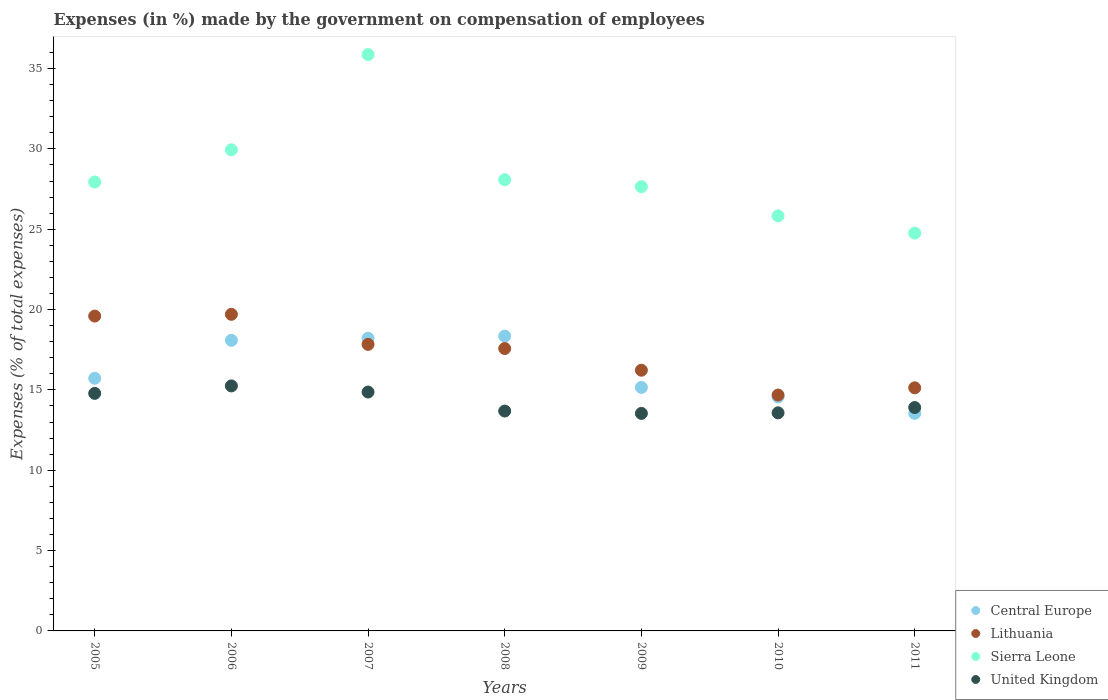How many different coloured dotlines are there?
Your answer should be compact. 4. Is the number of dotlines equal to the number of legend labels?
Offer a very short reply. Yes. What is the percentage of expenses made by the government on compensation of employees in Sierra Leone in 2005?
Keep it short and to the point. 27.94. Across all years, what is the maximum percentage of expenses made by the government on compensation of employees in United Kingdom?
Your answer should be compact. 15.25. Across all years, what is the minimum percentage of expenses made by the government on compensation of employees in Sierra Leone?
Your answer should be compact. 24.76. In which year was the percentage of expenses made by the government on compensation of employees in Sierra Leone minimum?
Keep it short and to the point. 2011. What is the total percentage of expenses made by the government on compensation of employees in Central Europe in the graph?
Offer a very short reply. 113.63. What is the difference between the percentage of expenses made by the government on compensation of employees in United Kingdom in 2006 and that in 2008?
Your answer should be very brief. 1.56. What is the difference between the percentage of expenses made by the government on compensation of employees in Central Europe in 2011 and the percentage of expenses made by the government on compensation of employees in Lithuania in 2007?
Your answer should be compact. -4.3. What is the average percentage of expenses made by the government on compensation of employees in Lithuania per year?
Offer a terse response. 17.25. In the year 2007, what is the difference between the percentage of expenses made by the government on compensation of employees in Central Europe and percentage of expenses made by the government on compensation of employees in United Kingdom?
Provide a short and direct response. 3.35. In how many years, is the percentage of expenses made by the government on compensation of employees in Central Europe greater than 27 %?
Offer a terse response. 0. What is the ratio of the percentage of expenses made by the government on compensation of employees in Central Europe in 2007 to that in 2011?
Keep it short and to the point. 1.35. Is the difference between the percentage of expenses made by the government on compensation of employees in Central Europe in 2005 and 2011 greater than the difference between the percentage of expenses made by the government on compensation of employees in United Kingdom in 2005 and 2011?
Ensure brevity in your answer.  Yes. What is the difference between the highest and the second highest percentage of expenses made by the government on compensation of employees in Lithuania?
Your answer should be very brief. 0.11. What is the difference between the highest and the lowest percentage of expenses made by the government on compensation of employees in Sierra Leone?
Provide a short and direct response. 11.11. Is it the case that in every year, the sum of the percentage of expenses made by the government on compensation of employees in Lithuania and percentage of expenses made by the government on compensation of employees in United Kingdom  is greater than the sum of percentage of expenses made by the government on compensation of employees in Central Europe and percentage of expenses made by the government on compensation of employees in Sierra Leone?
Make the answer very short. No. Is it the case that in every year, the sum of the percentage of expenses made by the government on compensation of employees in Lithuania and percentage of expenses made by the government on compensation of employees in Central Europe  is greater than the percentage of expenses made by the government on compensation of employees in United Kingdom?
Give a very brief answer. Yes. Does the percentage of expenses made by the government on compensation of employees in Sierra Leone monotonically increase over the years?
Your answer should be very brief. No. Is the percentage of expenses made by the government on compensation of employees in United Kingdom strictly less than the percentage of expenses made by the government on compensation of employees in Lithuania over the years?
Provide a short and direct response. Yes. How many years are there in the graph?
Provide a short and direct response. 7. Are the values on the major ticks of Y-axis written in scientific E-notation?
Offer a very short reply. No. Does the graph contain any zero values?
Offer a very short reply. No. Does the graph contain grids?
Your response must be concise. No. Where does the legend appear in the graph?
Keep it short and to the point. Bottom right. How many legend labels are there?
Offer a very short reply. 4. How are the legend labels stacked?
Keep it short and to the point. Vertical. What is the title of the graph?
Your answer should be compact. Expenses (in %) made by the government on compensation of employees. What is the label or title of the X-axis?
Your response must be concise. Years. What is the label or title of the Y-axis?
Your response must be concise. Expenses (% of total expenses). What is the Expenses (% of total expenses) in Central Europe in 2005?
Your answer should be compact. 15.72. What is the Expenses (% of total expenses) in Lithuania in 2005?
Provide a short and direct response. 19.59. What is the Expenses (% of total expenses) of Sierra Leone in 2005?
Your answer should be very brief. 27.94. What is the Expenses (% of total expenses) of United Kingdom in 2005?
Keep it short and to the point. 14.78. What is the Expenses (% of total expenses) of Central Europe in 2006?
Ensure brevity in your answer.  18.09. What is the Expenses (% of total expenses) in Lithuania in 2006?
Keep it short and to the point. 19.7. What is the Expenses (% of total expenses) in Sierra Leone in 2006?
Your answer should be compact. 29.94. What is the Expenses (% of total expenses) of United Kingdom in 2006?
Ensure brevity in your answer.  15.25. What is the Expenses (% of total expenses) in Central Europe in 2007?
Provide a succinct answer. 18.22. What is the Expenses (% of total expenses) in Lithuania in 2007?
Your response must be concise. 17.83. What is the Expenses (% of total expenses) of Sierra Leone in 2007?
Provide a succinct answer. 35.87. What is the Expenses (% of total expenses) of United Kingdom in 2007?
Ensure brevity in your answer.  14.87. What is the Expenses (% of total expenses) of Central Europe in 2008?
Keep it short and to the point. 18.35. What is the Expenses (% of total expenses) of Lithuania in 2008?
Offer a very short reply. 17.57. What is the Expenses (% of total expenses) of Sierra Leone in 2008?
Make the answer very short. 28.08. What is the Expenses (% of total expenses) of United Kingdom in 2008?
Your answer should be very brief. 13.68. What is the Expenses (% of total expenses) of Central Europe in 2009?
Provide a succinct answer. 15.16. What is the Expenses (% of total expenses) in Lithuania in 2009?
Your answer should be very brief. 16.23. What is the Expenses (% of total expenses) of Sierra Leone in 2009?
Offer a very short reply. 27.65. What is the Expenses (% of total expenses) of United Kingdom in 2009?
Ensure brevity in your answer.  13.54. What is the Expenses (% of total expenses) in Central Europe in 2010?
Give a very brief answer. 14.56. What is the Expenses (% of total expenses) of Lithuania in 2010?
Provide a short and direct response. 14.68. What is the Expenses (% of total expenses) in Sierra Leone in 2010?
Your answer should be very brief. 25.83. What is the Expenses (% of total expenses) in United Kingdom in 2010?
Provide a succinct answer. 13.57. What is the Expenses (% of total expenses) of Central Europe in 2011?
Your answer should be very brief. 13.54. What is the Expenses (% of total expenses) of Lithuania in 2011?
Provide a succinct answer. 15.13. What is the Expenses (% of total expenses) in Sierra Leone in 2011?
Your response must be concise. 24.76. What is the Expenses (% of total expenses) in United Kingdom in 2011?
Your response must be concise. 13.9. Across all years, what is the maximum Expenses (% of total expenses) of Central Europe?
Provide a succinct answer. 18.35. Across all years, what is the maximum Expenses (% of total expenses) of Lithuania?
Your answer should be compact. 19.7. Across all years, what is the maximum Expenses (% of total expenses) in Sierra Leone?
Provide a short and direct response. 35.87. Across all years, what is the maximum Expenses (% of total expenses) in United Kingdom?
Offer a very short reply. 15.25. Across all years, what is the minimum Expenses (% of total expenses) in Central Europe?
Provide a short and direct response. 13.54. Across all years, what is the minimum Expenses (% of total expenses) in Lithuania?
Give a very brief answer. 14.68. Across all years, what is the minimum Expenses (% of total expenses) in Sierra Leone?
Make the answer very short. 24.76. Across all years, what is the minimum Expenses (% of total expenses) of United Kingdom?
Your response must be concise. 13.54. What is the total Expenses (% of total expenses) in Central Europe in the graph?
Make the answer very short. 113.63. What is the total Expenses (% of total expenses) in Lithuania in the graph?
Your response must be concise. 120.74. What is the total Expenses (% of total expenses) in Sierra Leone in the graph?
Provide a short and direct response. 200.08. What is the total Expenses (% of total expenses) in United Kingdom in the graph?
Your answer should be very brief. 99.6. What is the difference between the Expenses (% of total expenses) of Central Europe in 2005 and that in 2006?
Offer a very short reply. -2.36. What is the difference between the Expenses (% of total expenses) of Lithuania in 2005 and that in 2006?
Keep it short and to the point. -0.11. What is the difference between the Expenses (% of total expenses) of Sierra Leone in 2005 and that in 2006?
Your answer should be compact. -2. What is the difference between the Expenses (% of total expenses) of United Kingdom in 2005 and that in 2006?
Keep it short and to the point. -0.47. What is the difference between the Expenses (% of total expenses) in Central Europe in 2005 and that in 2007?
Make the answer very short. -2.49. What is the difference between the Expenses (% of total expenses) in Lithuania in 2005 and that in 2007?
Offer a very short reply. 1.76. What is the difference between the Expenses (% of total expenses) in Sierra Leone in 2005 and that in 2007?
Provide a short and direct response. -7.93. What is the difference between the Expenses (% of total expenses) in United Kingdom in 2005 and that in 2007?
Your answer should be very brief. -0.08. What is the difference between the Expenses (% of total expenses) of Central Europe in 2005 and that in 2008?
Ensure brevity in your answer.  -2.63. What is the difference between the Expenses (% of total expenses) of Lithuania in 2005 and that in 2008?
Make the answer very short. 2.02. What is the difference between the Expenses (% of total expenses) in Sierra Leone in 2005 and that in 2008?
Make the answer very short. -0.14. What is the difference between the Expenses (% of total expenses) of United Kingdom in 2005 and that in 2008?
Make the answer very short. 1.1. What is the difference between the Expenses (% of total expenses) in Central Europe in 2005 and that in 2009?
Your answer should be compact. 0.57. What is the difference between the Expenses (% of total expenses) in Lithuania in 2005 and that in 2009?
Your answer should be compact. 3.37. What is the difference between the Expenses (% of total expenses) of Sierra Leone in 2005 and that in 2009?
Your answer should be compact. 0.29. What is the difference between the Expenses (% of total expenses) of United Kingdom in 2005 and that in 2009?
Provide a succinct answer. 1.25. What is the difference between the Expenses (% of total expenses) of Central Europe in 2005 and that in 2010?
Offer a terse response. 1.16. What is the difference between the Expenses (% of total expenses) of Lithuania in 2005 and that in 2010?
Your response must be concise. 4.91. What is the difference between the Expenses (% of total expenses) in Sierra Leone in 2005 and that in 2010?
Provide a succinct answer. 2.11. What is the difference between the Expenses (% of total expenses) of United Kingdom in 2005 and that in 2010?
Give a very brief answer. 1.21. What is the difference between the Expenses (% of total expenses) in Central Europe in 2005 and that in 2011?
Your answer should be very brief. 2.18. What is the difference between the Expenses (% of total expenses) in Lithuania in 2005 and that in 2011?
Your answer should be very brief. 4.46. What is the difference between the Expenses (% of total expenses) in Sierra Leone in 2005 and that in 2011?
Provide a short and direct response. 3.18. What is the difference between the Expenses (% of total expenses) of United Kingdom in 2005 and that in 2011?
Keep it short and to the point. 0.88. What is the difference between the Expenses (% of total expenses) in Central Europe in 2006 and that in 2007?
Make the answer very short. -0.13. What is the difference between the Expenses (% of total expenses) of Lithuania in 2006 and that in 2007?
Your answer should be very brief. 1.87. What is the difference between the Expenses (% of total expenses) in Sierra Leone in 2006 and that in 2007?
Offer a terse response. -5.93. What is the difference between the Expenses (% of total expenses) of United Kingdom in 2006 and that in 2007?
Your response must be concise. 0.38. What is the difference between the Expenses (% of total expenses) of Central Europe in 2006 and that in 2008?
Offer a terse response. -0.26. What is the difference between the Expenses (% of total expenses) of Lithuania in 2006 and that in 2008?
Ensure brevity in your answer.  2.13. What is the difference between the Expenses (% of total expenses) of Sierra Leone in 2006 and that in 2008?
Offer a terse response. 1.86. What is the difference between the Expenses (% of total expenses) in United Kingdom in 2006 and that in 2008?
Give a very brief answer. 1.56. What is the difference between the Expenses (% of total expenses) in Central Europe in 2006 and that in 2009?
Give a very brief answer. 2.93. What is the difference between the Expenses (% of total expenses) in Lithuania in 2006 and that in 2009?
Give a very brief answer. 3.48. What is the difference between the Expenses (% of total expenses) in Sierra Leone in 2006 and that in 2009?
Your response must be concise. 2.29. What is the difference between the Expenses (% of total expenses) of United Kingdom in 2006 and that in 2009?
Ensure brevity in your answer.  1.71. What is the difference between the Expenses (% of total expenses) of Central Europe in 2006 and that in 2010?
Ensure brevity in your answer.  3.53. What is the difference between the Expenses (% of total expenses) of Lithuania in 2006 and that in 2010?
Ensure brevity in your answer.  5.02. What is the difference between the Expenses (% of total expenses) of Sierra Leone in 2006 and that in 2010?
Your answer should be very brief. 4.11. What is the difference between the Expenses (% of total expenses) of United Kingdom in 2006 and that in 2010?
Make the answer very short. 1.67. What is the difference between the Expenses (% of total expenses) in Central Europe in 2006 and that in 2011?
Provide a short and direct response. 4.55. What is the difference between the Expenses (% of total expenses) in Lithuania in 2006 and that in 2011?
Keep it short and to the point. 4.57. What is the difference between the Expenses (% of total expenses) of Sierra Leone in 2006 and that in 2011?
Ensure brevity in your answer.  5.18. What is the difference between the Expenses (% of total expenses) of United Kingdom in 2006 and that in 2011?
Your answer should be very brief. 1.35. What is the difference between the Expenses (% of total expenses) of Central Europe in 2007 and that in 2008?
Ensure brevity in your answer.  -0.13. What is the difference between the Expenses (% of total expenses) in Lithuania in 2007 and that in 2008?
Your response must be concise. 0.26. What is the difference between the Expenses (% of total expenses) of Sierra Leone in 2007 and that in 2008?
Give a very brief answer. 7.79. What is the difference between the Expenses (% of total expenses) in United Kingdom in 2007 and that in 2008?
Offer a very short reply. 1.18. What is the difference between the Expenses (% of total expenses) in Central Europe in 2007 and that in 2009?
Your answer should be compact. 3.06. What is the difference between the Expenses (% of total expenses) of Lithuania in 2007 and that in 2009?
Offer a terse response. 1.61. What is the difference between the Expenses (% of total expenses) in Sierra Leone in 2007 and that in 2009?
Give a very brief answer. 8.22. What is the difference between the Expenses (% of total expenses) of United Kingdom in 2007 and that in 2009?
Offer a very short reply. 1.33. What is the difference between the Expenses (% of total expenses) in Central Europe in 2007 and that in 2010?
Offer a very short reply. 3.65. What is the difference between the Expenses (% of total expenses) of Lithuania in 2007 and that in 2010?
Keep it short and to the point. 3.15. What is the difference between the Expenses (% of total expenses) of Sierra Leone in 2007 and that in 2010?
Provide a short and direct response. 10.04. What is the difference between the Expenses (% of total expenses) in United Kingdom in 2007 and that in 2010?
Your answer should be compact. 1.29. What is the difference between the Expenses (% of total expenses) of Central Europe in 2007 and that in 2011?
Provide a succinct answer. 4.68. What is the difference between the Expenses (% of total expenses) in Lithuania in 2007 and that in 2011?
Make the answer very short. 2.7. What is the difference between the Expenses (% of total expenses) of Sierra Leone in 2007 and that in 2011?
Provide a short and direct response. 11.11. What is the difference between the Expenses (% of total expenses) in United Kingdom in 2007 and that in 2011?
Your response must be concise. 0.97. What is the difference between the Expenses (% of total expenses) in Central Europe in 2008 and that in 2009?
Your response must be concise. 3.19. What is the difference between the Expenses (% of total expenses) of Lithuania in 2008 and that in 2009?
Give a very brief answer. 1.35. What is the difference between the Expenses (% of total expenses) in Sierra Leone in 2008 and that in 2009?
Provide a short and direct response. 0.43. What is the difference between the Expenses (% of total expenses) of United Kingdom in 2008 and that in 2009?
Offer a very short reply. 0.15. What is the difference between the Expenses (% of total expenses) in Central Europe in 2008 and that in 2010?
Your answer should be very brief. 3.79. What is the difference between the Expenses (% of total expenses) of Lithuania in 2008 and that in 2010?
Make the answer very short. 2.89. What is the difference between the Expenses (% of total expenses) in Sierra Leone in 2008 and that in 2010?
Your response must be concise. 2.25. What is the difference between the Expenses (% of total expenses) of United Kingdom in 2008 and that in 2010?
Your answer should be compact. 0.11. What is the difference between the Expenses (% of total expenses) of Central Europe in 2008 and that in 2011?
Ensure brevity in your answer.  4.81. What is the difference between the Expenses (% of total expenses) of Lithuania in 2008 and that in 2011?
Give a very brief answer. 2.44. What is the difference between the Expenses (% of total expenses) in Sierra Leone in 2008 and that in 2011?
Make the answer very short. 3.32. What is the difference between the Expenses (% of total expenses) of United Kingdom in 2008 and that in 2011?
Your answer should be very brief. -0.22. What is the difference between the Expenses (% of total expenses) of Central Europe in 2009 and that in 2010?
Offer a terse response. 0.59. What is the difference between the Expenses (% of total expenses) of Lithuania in 2009 and that in 2010?
Keep it short and to the point. 1.54. What is the difference between the Expenses (% of total expenses) of Sierra Leone in 2009 and that in 2010?
Your response must be concise. 1.82. What is the difference between the Expenses (% of total expenses) of United Kingdom in 2009 and that in 2010?
Give a very brief answer. -0.04. What is the difference between the Expenses (% of total expenses) in Central Europe in 2009 and that in 2011?
Give a very brief answer. 1.62. What is the difference between the Expenses (% of total expenses) in Lithuania in 2009 and that in 2011?
Your response must be concise. 1.09. What is the difference between the Expenses (% of total expenses) of Sierra Leone in 2009 and that in 2011?
Give a very brief answer. 2.89. What is the difference between the Expenses (% of total expenses) in United Kingdom in 2009 and that in 2011?
Provide a succinct answer. -0.36. What is the difference between the Expenses (% of total expenses) of Central Europe in 2010 and that in 2011?
Your answer should be compact. 1.02. What is the difference between the Expenses (% of total expenses) of Lithuania in 2010 and that in 2011?
Offer a very short reply. -0.45. What is the difference between the Expenses (% of total expenses) in Sierra Leone in 2010 and that in 2011?
Keep it short and to the point. 1.07. What is the difference between the Expenses (% of total expenses) of United Kingdom in 2010 and that in 2011?
Provide a short and direct response. -0.33. What is the difference between the Expenses (% of total expenses) of Central Europe in 2005 and the Expenses (% of total expenses) of Lithuania in 2006?
Provide a short and direct response. -3.98. What is the difference between the Expenses (% of total expenses) in Central Europe in 2005 and the Expenses (% of total expenses) in Sierra Leone in 2006?
Offer a very short reply. -14.22. What is the difference between the Expenses (% of total expenses) in Central Europe in 2005 and the Expenses (% of total expenses) in United Kingdom in 2006?
Offer a terse response. 0.47. What is the difference between the Expenses (% of total expenses) in Lithuania in 2005 and the Expenses (% of total expenses) in Sierra Leone in 2006?
Keep it short and to the point. -10.35. What is the difference between the Expenses (% of total expenses) of Lithuania in 2005 and the Expenses (% of total expenses) of United Kingdom in 2006?
Your response must be concise. 4.35. What is the difference between the Expenses (% of total expenses) of Sierra Leone in 2005 and the Expenses (% of total expenses) of United Kingdom in 2006?
Your answer should be very brief. 12.69. What is the difference between the Expenses (% of total expenses) in Central Europe in 2005 and the Expenses (% of total expenses) in Lithuania in 2007?
Keep it short and to the point. -2.11. What is the difference between the Expenses (% of total expenses) in Central Europe in 2005 and the Expenses (% of total expenses) in Sierra Leone in 2007?
Your answer should be compact. -20.15. What is the difference between the Expenses (% of total expenses) in Central Europe in 2005 and the Expenses (% of total expenses) in United Kingdom in 2007?
Offer a terse response. 0.86. What is the difference between the Expenses (% of total expenses) of Lithuania in 2005 and the Expenses (% of total expenses) of Sierra Leone in 2007?
Make the answer very short. -16.28. What is the difference between the Expenses (% of total expenses) of Lithuania in 2005 and the Expenses (% of total expenses) of United Kingdom in 2007?
Make the answer very short. 4.73. What is the difference between the Expenses (% of total expenses) in Sierra Leone in 2005 and the Expenses (% of total expenses) in United Kingdom in 2007?
Offer a very short reply. 13.07. What is the difference between the Expenses (% of total expenses) in Central Europe in 2005 and the Expenses (% of total expenses) in Lithuania in 2008?
Offer a very short reply. -1.85. What is the difference between the Expenses (% of total expenses) in Central Europe in 2005 and the Expenses (% of total expenses) in Sierra Leone in 2008?
Your answer should be very brief. -12.36. What is the difference between the Expenses (% of total expenses) in Central Europe in 2005 and the Expenses (% of total expenses) in United Kingdom in 2008?
Your answer should be very brief. 2.04. What is the difference between the Expenses (% of total expenses) in Lithuania in 2005 and the Expenses (% of total expenses) in Sierra Leone in 2008?
Provide a succinct answer. -8.49. What is the difference between the Expenses (% of total expenses) of Lithuania in 2005 and the Expenses (% of total expenses) of United Kingdom in 2008?
Keep it short and to the point. 5.91. What is the difference between the Expenses (% of total expenses) of Sierra Leone in 2005 and the Expenses (% of total expenses) of United Kingdom in 2008?
Your response must be concise. 14.25. What is the difference between the Expenses (% of total expenses) of Central Europe in 2005 and the Expenses (% of total expenses) of Lithuania in 2009?
Your answer should be very brief. -0.5. What is the difference between the Expenses (% of total expenses) of Central Europe in 2005 and the Expenses (% of total expenses) of Sierra Leone in 2009?
Give a very brief answer. -11.93. What is the difference between the Expenses (% of total expenses) in Central Europe in 2005 and the Expenses (% of total expenses) in United Kingdom in 2009?
Offer a terse response. 2.18. What is the difference between the Expenses (% of total expenses) of Lithuania in 2005 and the Expenses (% of total expenses) of Sierra Leone in 2009?
Make the answer very short. -8.05. What is the difference between the Expenses (% of total expenses) of Lithuania in 2005 and the Expenses (% of total expenses) of United Kingdom in 2009?
Provide a succinct answer. 6.06. What is the difference between the Expenses (% of total expenses) of Sierra Leone in 2005 and the Expenses (% of total expenses) of United Kingdom in 2009?
Keep it short and to the point. 14.4. What is the difference between the Expenses (% of total expenses) of Central Europe in 2005 and the Expenses (% of total expenses) of Lithuania in 2010?
Your answer should be very brief. 1.04. What is the difference between the Expenses (% of total expenses) in Central Europe in 2005 and the Expenses (% of total expenses) in Sierra Leone in 2010?
Offer a very short reply. -10.11. What is the difference between the Expenses (% of total expenses) in Central Europe in 2005 and the Expenses (% of total expenses) in United Kingdom in 2010?
Your answer should be compact. 2.15. What is the difference between the Expenses (% of total expenses) of Lithuania in 2005 and the Expenses (% of total expenses) of Sierra Leone in 2010?
Provide a short and direct response. -6.24. What is the difference between the Expenses (% of total expenses) in Lithuania in 2005 and the Expenses (% of total expenses) in United Kingdom in 2010?
Offer a terse response. 6.02. What is the difference between the Expenses (% of total expenses) of Sierra Leone in 2005 and the Expenses (% of total expenses) of United Kingdom in 2010?
Keep it short and to the point. 14.37. What is the difference between the Expenses (% of total expenses) in Central Europe in 2005 and the Expenses (% of total expenses) in Lithuania in 2011?
Offer a terse response. 0.59. What is the difference between the Expenses (% of total expenses) of Central Europe in 2005 and the Expenses (% of total expenses) of Sierra Leone in 2011?
Offer a terse response. -9.04. What is the difference between the Expenses (% of total expenses) in Central Europe in 2005 and the Expenses (% of total expenses) in United Kingdom in 2011?
Offer a terse response. 1.82. What is the difference between the Expenses (% of total expenses) in Lithuania in 2005 and the Expenses (% of total expenses) in Sierra Leone in 2011?
Offer a terse response. -5.16. What is the difference between the Expenses (% of total expenses) of Lithuania in 2005 and the Expenses (% of total expenses) of United Kingdom in 2011?
Provide a succinct answer. 5.69. What is the difference between the Expenses (% of total expenses) of Sierra Leone in 2005 and the Expenses (% of total expenses) of United Kingdom in 2011?
Your answer should be very brief. 14.04. What is the difference between the Expenses (% of total expenses) in Central Europe in 2006 and the Expenses (% of total expenses) in Lithuania in 2007?
Offer a terse response. 0.25. What is the difference between the Expenses (% of total expenses) of Central Europe in 2006 and the Expenses (% of total expenses) of Sierra Leone in 2007?
Your answer should be compact. -17.79. What is the difference between the Expenses (% of total expenses) in Central Europe in 2006 and the Expenses (% of total expenses) in United Kingdom in 2007?
Your answer should be very brief. 3.22. What is the difference between the Expenses (% of total expenses) of Lithuania in 2006 and the Expenses (% of total expenses) of Sierra Leone in 2007?
Offer a terse response. -16.17. What is the difference between the Expenses (% of total expenses) of Lithuania in 2006 and the Expenses (% of total expenses) of United Kingdom in 2007?
Your answer should be compact. 4.84. What is the difference between the Expenses (% of total expenses) in Sierra Leone in 2006 and the Expenses (% of total expenses) in United Kingdom in 2007?
Provide a succinct answer. 15.08. What is the difference between the Expenses (% of total expenses) of Central Europe in 2006 and the Expenses (% of total expenses) of Lithuania in 2008?
Offer a very short reply. 0.51. What is the difference between the Expenses (% of total expenses) of Central Europe in 2006 and the Expenses (% of total expenses) of Sierra Leone in 2008?
Your answer should be compact. -9.99. What is the difference between the Expenses (% of total expenses) of Central Europe in 2006 and the Expenses (% of total expenses) of United Kingdom in 2008?
Offer a very short reply. 4.4. What is the difference between the Expenses (% of total expenses) of Lithuania in 2006 and the Expenses (% of total expenses) of Sierra Leone in 2008?
Your answer should be compact. -8.38. What is the difference between the Expenses (% of total expenses) of Lithuania in 2006 and the Expenses (% of total expenses) of United Kingdom in 2008?
Your response must be concise. 6.02. What is the difference between the Expenses (% of total expenses) of Sierra Leone in 2006 and the Expenses (% of total expenses) of United Kingdom in 2008?
Offer a terse response. 16.26. What is the difference between the Expenses (% of total expenses) in Central Europe in 2006 and the Expenses (% of total expenses) in Lithuania in 2009?
Your answer should be compact. 1.86. What is the difference between the Expenses (% of total expenses) of Central Europe in 2006 and the Expenses (% of total expenses) of Sierra Leone in 2009?
Give a very brief answer. -9.56. What is the difference between the Expenses (% of total expenses) in Central Europe in 2006 and the Expenses (% of total expenses) in United Kingdom in 2009?
Make the answer very short. 4.55. What is the difference between the Expenses (% of total expenses) of Lithuania in 2006 and the Expenses (% of total expenses) of Sierra Leone in 2009?
Provide a short and direct response. -7.95. What is the difference between the Expenses (% of total expenses) in Lithuania in 2006 and the Expenses (% of total expenses) in United Kingdom in 2009?
Keep it short and to the point. 6.17. What is the difference between the Expenses (% of total expenses) in Sierra Leone in 2006 and the Expenses (% of total expenses) in United Kingdom in 2009?
Your answer should be very brief. 16.41. What is the difference between the Expenses (% of total expenses) in Central Europe in 2006 and the Expenses (% of total expenses) in Lithuania in 2010?
Provide a short and direct response. 3.41. What is the difference between the Expenses (% of total expenses) in Central Europe in 2006 and the Expenses (% of total expenses) in Sierra Leone in 2010?
Make the answer very short. -7.74. What is the difference between the Expenses (% of total expenses) in Central Europe in 2006 and the Expenses (% of total expenses) in United Kingdom in 2010?
Provide a short and direct response. 4.51. What is the difference between the Expenses (% of total expenses) of Lithuania in 2006 and the Expenses (% of total expenses) of Sierra Leone in 2010?
Keep it short and to the point. -6.13. What is the difference between the Expenses (% of total expenses) of Lithuania in 2006 and the Expenses (% of total expenses) of United Kingdom in 2010?
Provide a succinct answer. 6.13. What is the difference between the Expenses (% of total expenses) of Sierra Leone in 2006 and the Expenses (% of total expenses) of United Kingdom in 2010?
Provide a succinct answer. 16.37. What is the difference between the Expenses (% of total expenses) of Central Europe in 2006 and the Expenses (% of total expenses) of Lithuania in 2011?
Offer a very short reply. 2.96. What is the difference between the Expenses (% of total expenses) in Central Europe in 2006 and the Expenses (% of total expenses) in Sierra Leone in 2011?
Your response must be concise. -6.67. What is the difference between the Expenses (% of total expenses) of Central Europe in 2006 and the Expenses (% of total expenses) of United Kingdom in 2011?
Your response must be concise. 4.18. What is the difference between the Expenses (% of total expenses) of Lithuania in 2006 and the Expenses (% of total expenses) of Sierra Leone in 2011?
Your answer should be very brief. -5.05. What is the difference between the Expenses (% of total expenses) in Lithuania in 2006 and the Expenses (% of total expenses) in United Kingdom in 2011?
Offer a terse response. 5.8. What is the difference between the Expenses (% of total expenses) in Sierra Leone in 2006 and the Expenses (% of total expenses) in United Kingdom in 2011?
Give a very brief answer. 16.04. What is the difference between the Expenses (% of total expenses) in Central Europe in 2007 and the Expenses (% of total expenses) in Lithuania in 2008?
Ensure brevity in your answer.  0.64. What is the difference between the Expenses (% of total expenses) in Central Europe in 2007 and the Expenses (% of total expenses) in Sierra Leone in 2008?
Your answer should be compact. -9.87. What is the difference between the Expenses (% of total expenses) in Central Europe in 2007 and the Expenses (% of total expenses) in United Kingdom in 2008?
Provide a succinct answer. 4.53. What is the difference between the Expenses (% of total expenses) of Lithuania in 2007 and the Expenses (% of total expenses) of Sierra Leone in 2008?
Make the answer very short. -10.25. What is the difference between the Expenses (% of total expenses) in Lithuania in 2007 and the Expenses (% of total expenses) in United Kingdom in 2008?
Your answer should be compact. 4.15. What is the difference between the Expenses (% of total expenses) of Sierra Leone in 2007 and the Expenses (% of total expenses) of United Kingdom in 2008?
Your answer should be very brief. 22.19. What is the difference between the Expenses (% of total expenses) in Central Europe in 2007 and the Expenses (% of total expenses) in Lithuania in 2009?
Ensure brevity in your answer.  1.99. What is the difference between the Expenses (% of total expenses) in Central Europe in 2007 and the Expenses (% of total expenses) in Sierra Leone in 2009?
Ensure brevity in your answer.  -9.43. What is the difference between the Expenses (% of total expenses) of Central Europe in 2007 and the Expenses (% of total expenses) of United Kingdom in 2009?
Make the answer very short. 4.68. What is the difference between the Expenses (% of total expenses) of Lithuania in 2007 and the Expenses (% of total expenses) of Sierra Leone in 2009?
Offer a very short reply. -9.82. What is the difference between the Expenses (% of total expenses) in Lithuania in 2007 and the Expenses (% of total expenses) in United Kingdom in 2009?
Keep it short and to the point. 4.3. What is the difference between the Expenses (% of total expenses) of Sierra Leone in 2007 and the Expenses (% of total expenses) of United Kingdom in 2009?
Make the answer very short. 22.34. What is the difference between the Expenses (% of total expenses) of Central Europe in 2007 and the Expenses (% of total expenses) of Lithuania in 2010?
Your answer should be compact. 3.54. What is the difference between the Expenses (% of total expenses) of Central Europe in 2007 and the Expenses (% of total expenses) of Sierra Leone in 2010?
Your answer should be compact. -7.62. What is the difference between the Expenses (% of total expenses) in Central Europe in 2007 and the Expenses (% of total expenses) in United Kingdom in 2010?
Keep it short and to the point. 4.64. What is the difference between the Expenses (% of total expenses) in Lithuania in 2007 and the Expenses (% of total expenses) in Sierra Leone in 2010?
Ensure brevity in your answer.  -8. What is the difference between the Expenses (% of total expenses) of Lithuania in 2007 and the Expenses (% of total expenses) of United Kingdom in 2010?
Your answer should be compact. 4.26. What is the difference between the Expenses (% of total expenses) of Sierra Leone in 2007 and the Expenses (% of total expenses) of United Kingdom in 2010?
Keep it short and to the point. 22.3. What is the difference between the Expenses (% of total expenses) in Central Europe in 2007 and the Expenses (% of total expenses) in Lithuania in 2011?
Offer a very short reply. 3.09. What is the difference between the Expenses (% of total expenses) of Central Europe in 2007 and the Expenses (% of total expenses) of Sierra Leone in 2011?
Ensure brevity in your answer.  -6.54. What is the difference between the Expenses (% of total expenses) in Central Europe in 2007 and the Expenses (% of total expenses) in United Kingdom in 2011?
Provide a succinct answer. 4.31. What is the difference between the Expenses (% of total expenses) in Lithuania in 2007 and the Expenses (% of total expenses) in Sierra Leone in 2011?
Provide a succinct answer. -6.92. What is the difference between the Expenses (% of total expenses) in Lithuania in 2007 and the Expenses (% of total expenses) in United Kingdom in 2011?
Provide a succinct answer. 3.93. What is the difference between the Expenses (% of total expenses) of Sierra Leone in 2007 and the Expenses (% of total expenses) of United Kingdom in 2011?
Keep it short and to the point. 21.97. What is the difference between the Expenses (% of total expenses) in Central Europe in 2008 and the Expenses (% of total expenses) in Lithuania in 2009?
Give a very brief answer. 2.12. What is the difference between the Expenses (% of total expenses) of Central Europe in 2008 and the Expenses (% of total expenses) of Sierra Leone in 2009?
Offer a terse response. -9.3. What is the difference between the Expenses (% of total expenses) in Central Europe in 2008 and the Expenses (% of total expenses) in United Kingdom in 2009?
Your answer should be very brief. 4.81. What is the difference between the Expenses (% of total expenses) in Lithuania in 2008 and the Expenses (% of total expenses) in Sierra Leone in 2009?
Make the answer very short. -10.07. What is the difference between the Expenses (% of total expenses) of Lithuania in 2008 and the Expenses (% of total expenses) of United Kingdom in 2009?
Provide a short and direct response. 4.04. What is the difference between the Expenses (% of total expenses) of Sierra Leone in 2008 and the Expenses (% of total expenses) of United Kingdom in 2009?
Give a very brief answer. 14.54. What is the difference between the Expenses (% of total expenses) of Central Europe in 2008 and the Expenses (% of total expenses) of Lithuania in 2010?
Offer a terse response. 3.67. What is the difference between the Expenses (% of total expenses) of Central Europe in 2008 and the Expenses (% of total expenses) of Sierra Leone in 2010?
Give a very brief answer. -7.48. What is the difference between the Expenses (% of total expenses) in Central Europe in 2008 and the Expenses (% of total expenses) in United Kingdom in 2010?
Keep it short and to the point. 4.77. What is the difference between the Expenses (% of total expenses) of Lithuania in 2008 and the Expenses (% of total expenses) of Sierra Leone in 2010?
Provide a short and direct response. -8.26. What is the difference between the Expenses (% of total expenses) of Lithuania in 2008 and the Expenses (% of total expenses) of United Kingdom in 2010?
Your answer should be very brief. 4. What is the difference between the Expenses (% of total expenses) of Sierra Leone in 2008 and the Expenses (% of total expenses) of United Kingdom in 2010?
Ensure brevity in your answer.  14.51. What is the difference between the Expenses (% of total expenses) of Central Europe in 2008 and the Expenses (% of total expenses) of Lithuania in 2011?
Make the answer very short. 3.22. What is the difference between the Expenses (% of total expenses) of Central Europe in 2008 and the Expenses (% of total expenses) of Sierra Leone in 2011?
Provide a short and direct response. -6.41. What is the difference between the Expenses (% of total expenses) in Central Europe in 2008 and the Expenses (% of total expenses) in United Kingdom in 2011?
Keep it short and to the point. 4.45. What is the difference between the Expenses (% of total expenses) of Lithuania in 2008 and the Expenses (% of total expenses) of Sierra Leone in 2011?
Offer a terse response. -7.18. What is the difference between the Expenses (% of total expenses) in Lithuania in 2008 and the Expenses (% of total expenses) in United Kingdom in 2011?
Your answer should be very brief. 3.67. What is the difference between the Expenses (% of total expenses) in Sierra Leone in 2008 and the Expenses (% of total expenses) in United Kingdom in 2011?
Offer a very short reply. 14.18. What is the difference between the Expenses (% of total expenses) in Central Europe in 2009 and the Expenses (% of total expenses) in Lithuania in 2010?
Offer a very short reply. 0.48. What is the difference between the Expenses (% of total expenses) in Central Europe in 2009 and the Expenses (% of total expenses) in Sierra Leone in 2010?
Your answer should be compact. -10.67. What is the difference between the Expenses (% of total expenses) of Central Europe in 2009 and the Expenses (% of total expenses) of United Kingdom in 2010?
Offer a terse response. 1.58. What is the difference between the Expenses (% of total expenses) in Lithuania in 2009 and the Expenses (% of total expenses) in Sierra Leone in 2010?
Keep it short and to the point. -9.61. What is the difference between the Expenses (% of total expenses) in Lithuania in 2009 and the Expenses (% of total expenses) in United Kingdom in 2010?
Offer a very short reply. 2.65. What is the difference between the Expenses (% of total expenses) of Sierra Leone in 2009 and the Expenses (% of total expenses) of United Kingdom in 2010?
Offer a very short reply. 14.08. What is the difference between the Expenses (% of total expenses) of Central Europe in 2009 and the Expenses (% of total expenses) of Lithuania in 2011?
Give a very brief answer. 0.03. What is the difference between the Expenses (% of total expenses) of Central Europe in 2009 and the Expenses (% of total expenses) of Sierra Leone in 2011?
Give a very brief answer. -9.6. What is the difference between the Expenses (% of total expenses) in Central Europe in 2009 and the Expenses (% of total expenses) in United Kingdom in 2011?
Provide a succinct answer. 1.25. What is the difference between the Expenses (% of total expenses) of Lithuania in 2009 and the Expenses (% of total expenses) of Sierra Leone in 2011?
Your answer should be very brief. -8.53. What is the difference between the Expenses (% of total expenses) of Lithuania in 2009 and the Expenses (% of total expenses) of United Kingdom in 2011?
Keep it short and to the point. 2.32. What is the difference between the Expenses (% of total expenses) in Sierra Leone in 2009 and the Expenses (% of total expenses) in United Kingdom in 2011?
Keep it short and to the point. 13.75. What is the difference between the Expenses (% of total expenses) in Central Europe in 2010 and the Expenses (% of total expenses) in Lithuania in 2011?
Your answer should be compact. -0.57. What is the difference between the Expenses (% of total expenses) in Central Europe in 2010 and the Expenses (% of total expenses) in Sierra Leone in 2011?
Your answer should be very brief. -10.2. What is the difference between the Expenses (% of total expenses) in Central Europe in 2010 and the Expenses (% of total expenses) in United Kingdom in 2011?
Give a very brief answer. 0.66. What is the difference between the Expenses (% of total expenses) of Lithuania in 2010 and the Expenses (% of total expenses) of Sierra Leone in 2011?
Your answer should be very brief. -10.08. What is the difference between the Expenses (% of total expenses) of Lithuania in 2010 and the Expenses (% of total expenses) of United Kingdom in 2011?
Your response must be concise. 0.78. What is the difference between the Expenses (% of total expenses) in Sierra Leone in 2010 and the Expenses (% of total expenses) in United Kingdom in 2011?
Your response must be concise. 11.93. What is the average Expenses (% of total expenses) of Central Europe per year?
Offer a terse response. 16.23. What is the average Expenses (% of total expenses) of Lithuania per year?
Offer a very short reply. 17.25. What is the average Expenses (% of total expenses) in Sierra Leone per year?
Provide a succinct answer. 28.58. What is the average Expenses (% of total expenses) in United Kingdom per year?
Your response must be concise. 14.23. In the year 2005, what is the difference between the Expenses (% of total expenses) in Central Europe and Expenses (% of total expenses) in Lithuania?
Your answer should be very brief. -3.87. In the year 2005, what is the difference between the Expenses (% of total expenses) of Central Europe and Expenses (% of total expenses) of Sierra Leone?
Offer a very short reply. -12.22. In the year 2005, what is the difference between the Expenses (% of total expenses) in Central Europe and Expenses (% of total expenses) in United Kingdom?
Your answer should be compact. 0.94. In the year 2005, what is the difference between the Expenses (% of total expenses) in Lithuania and Expenses (% of total expenses) in Sierra Leone?
Offer a very short reply. -8.34. In the year 2005, what is the difference between the Expenses (% of total expenses) in Lithuania and Expenses (% of total expenses) in United Kingdom?
Your answer should be compact. 4.81. In the year 2005, what is the difference between the Expenses (% of total expenses) of Sierra Leone and Expenses (% of total expenses) of United Kingdom?
Offer a terse response. 13.16. In the year 2006, what is the difference between the Expenses (% of total expenses) in Central Europe and Expenses (% of total expenses) in Lithuania?
Your answer should be compact. -1.62. In the year 2006, what is the difference between the Expenses (% of total expenses) of Central Europe and Expenses (% of total expenses) of Sierra Leone?
Offer a terse response. -11.86. In the year 2006, what is the difference between the Expenses (% of total expenses) of Central Europe and Expenses (% of total expenses) of United Kingdom?
Your answer should be compact. 2.84. In the year 2006, what is the difference between the Expenses (% of total expenses) in Lithuania and Expenses (% of total expenses) in Sierra Leone?
Offer a very short reply. -10.24. In the year 2006, what is the difference between the Expenses (% of total expenses) in Lithuania and Expenses (% of total expenses) in United Kingdom?
Your answer should be compact. 4.46. In the year 2006, what is the difference between the Expenses (% of total expenses) of Sierra Leone and Expenses (% of total expenses) of United Kingdom?
Offer a terse response. 14.7. In the year 2007, what is the difference between the Expenses (% of total expenses) of Central Europe and Expenses (% of total expenses) of Lithuania?
Provide a succinct answer. 0.38. In the year 2007, what is the difference between the Expenses (% of total expenses) of Central Europe and Expenses (% of total expenses) of Sierra Leone?
Your response must be concise. -17.66. In the year 2007, what is the difference between the Expenses (% of total expenses) of Central Europe and Expenses (% of total expenses) of United Kingdom?
Provide a succinct answer. 3.35. In the year 2007, what is the difference between the Expenses (% of total expenses) in Lithuania and Expenses (% of total expenses) in Sierra Leone?
Give a very brief answer. -18.04. In the year 2007, what is the difference between the Expenses (% of total expenses) in Lithuania and Expenses (% of total expenses) in United Kingdom?
Offer a very short reply. 2.97. In the year 2007, what is the difference between the Expenses (% of total expenses) in Sierra Leone and Expenses (% of total expenses) in United Kingdom?
Provide a succinct answer. 21.01. In the year 2008, what is the difference between the Expenses (% of total expenses) in Central Europe and Expenses (% of total expenses) in Lithuania?
Provide a short and direct response. 0.77. In the year 2008, what is the difference between the Expenses (% of total expenses) of Central Europe and Expenses (% of total expenses) of Sierra Leone?
Make the answer very short. -9.73. In the year 2008, what is the difference between the Expenses (% of total expenses) of Central Europe and Expenses (% of total expenses) of United Kingdom?
Your answer should be very brief. 4.66. In the year 2008, what is the difference between the Expenses (% of total expenses) in Lithuania and Expenses (% of total expenses) in Sierra Leone?
Provide a short and direct response. -10.51. In the year 2008, what is the difference between the Expenses (% of total expenses) of Lithuania and Expenses (% of total expenses) of United Kingdom?
Make the answer very short. 3.89. In the year 2008, what is the difference between the Expenses (% of total expenses) in Sierra Leone and Expenses (% of total expenses) in United Kingdom?
Ensure brevity in your answer.  14.4. In the year 2009, what is the difference between the Expenses (% of total expenses) of Central Europe and Expenses (% of total expenses) of Lithuania?
Offer a very short reply. -1.07. In the year 2009, what is the difference between the Expenses (% of total expenses) in Central Europe and Expenses (% of total expenses) in Sierra Leone?
Offer a very short reply. -12.49. In the year 2009, what is the difference between the Expenses (% of total expenses) in Central Europe and Expenses (% of total expenses) in United Kingdom?
Make the answer very short. 1.62. In the year 2009, what is the difference between the Expenses (% of total expenses) of Lithuania and Expenses (% of total expenses) of Sierra Leone?
Provide a succinct answer. -11.42. In the year 2009, what is the difference between the Expenses (% of total expenses) in Lithuania and Expenses (% of total expenses) in United Kingdom?
Your answer should be compact. 2.69. In the year 2009, what is the difference between the Expenses (% of total expenses) of Sierra Leone and Expenses (% of total expenses) of United Kingdom?
Provide a succinct answer. 14.11. In the year 2010, what is the difference between the Expenses (% of total expenses) of Central Europe and Expenses (% of total expenses) of Lithuania?
Give a very brief answer. -0.12. In the year 2010, what is the difference between the Expenses (% of total expenses) in Central Europe and Expenses (% of total expenses) in Sierra Leone?
Keep it short and to the point. -11.27. In the year 2010, what is the difference between the Expenses (% of total expenses) of Central Europe and Expenses (% of total expenses) of United Kingdom?
Give a very brief answer. 0.99. In the year 2010, what is the difference between the Expenses (% of total expenses) in Lithuania and Expenses (% of total expenses) in Sierra Leone?
Your answer should be very brief. -11.15. In the year 2010, what is the difference between the Expenses (% of total expenses) of Lithuania and Expenses (% of total expenses) of United Kingdom?
Keep it short and to the point. 1.11. In the year 2010, what is the difference between the Expenses (% of total expenses) of Sierra Leone and Expenses (% of total expenses) of United Kingdom?
Your answer should be compact. 12.26. In the year 2011, what is the difference between the Expenses (% of total expenses) of Central Europe and Expenses (% of total expenses) of Lithuania?
Your answer should be very brief. -1.59. In the year 2011, what is the difference between the Expenses (% of total expenses) of Central Europe and Expenses (% of total expenses) of Sierra Leone?
Offer a very short reply. -11.22. In the year 2011, what is the difference between the Expenses (% of total expenses) in Central Europe and Expenses (% of total expenses) in United Kingdom?
Your response must be concise. -0.36. In the year 2011, what is the difference between the Expenses (% of total expenses) of Lithuania and Expenses (% of total expenses) of Sierra Leone?
Your answer should be compact. -9.63. In the year 2011, what is the difference between the Expenses (% of total expenses) of Lithuania and Expenses (% of total expenses) of United Kingdom?
Give a very brief answer. 1.23. In the year 2011, what is the difference between the Expenses (% of total expenses) in Sierra Leone and Expenses (% of total expenses) in United Kingdom?
Your response must be concise. 10.86. What is the ratio of the Expenses (% of total expenses) of Central Europe in 2005 to that in 2006?
Keep it short and to the point. 0.87. What is the ratio of the Expenses (% of total expenses) in Sierra Leone in 2005 to that in 2006?
Make the answer very short. 0.93. What is the ratio of the Expenses (% of total expenses) of United Kingdom in 2005 to that in 2006?
Ensure brevity in your answer.  0.97. What is the ratio of the Expenses (% of total expenses) in Central Europe in 2005 to that in 2007?
Provide a short and direct response. 0.86. What is the ratio of the Expenses (% of total expenses) of Lithuania in 2005 to that in 2007?
Offer a very short reply. 1.1. What is the ratio of the Expenses (% of total expenses) of Sierra Leone in 2005 to that in 2007?
Provide a succinct answer. 0.78. What is the ratio of the Expenses (% of total expenses) of Central Europe in 2005 to that in 2008?
Keep it short and to the point. 0.86. What is the ratio of the Expenses (% of total expenses) in Lithuania in 2005 to that in 2008?
Ensure brevity in your answer.  1.11. What is the ratio of the Expenses (% of total expenses) of Sierra Leone in 2005 to that in 2008?
Provide a short and direct response. 0.99. What is the ratio of the Expenses (% of total expenses) of United Kingdom in 2005 to that in 2008?
Make the answer very short. 1.08. What is the ratio of the Expenses (% of total expenses) in Central Europe in 2005 to that in 2009?
Offer a very short reply. 1.04. What is the ratio of the Expenses (% of total expenses) in Lithuania in 2005 to that in 2009?
Provide a succinct answer. 1.21. What is the ratio of the Expenses (% of total expenses) in Sierra Leone in 2005 to that in 2009?
Give a very brief answer. 1.01. What is the ratio of the Expenses (% of total expenses) of United Kingdom in 2005 to that in 2009?
Your answer should be compact. 1.09. What is the ratio of the Expenses (% of total expenses) in Central Europe in 2005 to that in 2010?
Keep it short and to the point. 1.08. What is the ratio of the Expenses (% of total expenses) of Lithuania in 2005 to that in 2010?
Keep it short and to the point. 1.33. What is the ratio of the Expenses (% of total expenses) in Sierra Leone in 2005 to that in 2010?
Your answer should be compact. 1.08. What is the ratio of the Expenses (% of total expenses) in United Kingdom in 2005 to that in 2010?
Make the answer very short. 1.09. What is the ratio of the Expenses (% of total expenses) of Central Europe in 2005 to that in 2011?
Offer a terse response. 1.16. What is the ratio of the Expenses (% of total expenses) in Lithuania in 2005 to that in 2011?
Your response must be concise. 1.3. What is the ratio of the Expenses (% of total expenses) of Sierra Leone in 2005 to that in 2011?
Offer a very short reply. 1.13. What is the ratio of the Expenses (% of total expenses) of United Kingdom in 2005 to that in 2011?
Your answer should be compact. 1.06. What is the ratio of the Expenses (% of total expenses) in Lithuania in 2006 to that in 2007?
Provide a succinct answer. 1.1. What is the ratio of the Expenses (% of total expenses) of Sierra Leone in 2006 to that in 2007?
Provide a succinct answer. 0.83. What is the ratio of the Expenses (% of total expenses) of United Kingdom in 2006 to that in 2007?
Provide a succinct answer. 1.03. What is the ratio of the Expenses (% of total expenses) of Central Europe in 2006 to that in 2008?
Ensure brevity in your answer.  0.99. What is the ratio of the Expenses (% of total expenses) in Lithuania in 2006 to that in 2008?
Provide a short and direct response. 1.12. What is the ratio of the Expenses (% of total expenses) of Sierra Leone in 2006 to that in 2008?
Offer a very short reply. 1.07. What is the ratio of the Expenses (% of total expenses) of United Kingdom in 2006 to that in 2008?
Ensure brevity in your answer.  1.11. What is the ratio of the Expenses (% of total expenses) of Central Europe in 2006 to that in 2009?
Provide a short and direct response. 1.19. What is the ratio of the Expenses (% of total expenses) in Lithuania in 2006 to that in 2009?
Your response must be concise. 1.21. What is the ratio of the Expenses (% of total expenses) in Sierra Leone in 2006 to that in 2009?
Provide a succinct answer. 1.08. What is the ratio of the Expenses (% of total expenses) in United Kingdom in 2006 to that in 2009?
Provide a succinct answer. 1.13. What is the ratio of the Expenses (% of total expenses) in Central Europe in 2006 to that in 2010?
Keep it short and to the point. 1.24. What is the ratio of the Expenses (% of total expenses) of Lithuania in 2006 to that in 2010?
Your answer should be very brief. 1.34. What is the ratio of the Expenses (% of total expenses) of Sierra Leone in 2006 to that in 2010?
Ensure brevity in your answer.  1.16. What is the ratio of the Expenses (% of total expenses) of United Kingdom in 2006 to that in 2010?
Make the answer very short. 1.12. What is the ratio of the Expenses (% of total expenses) of Central Europe in 2006 to that in 2011?
Your answer should be compact. 1.34. What is the ratio of the Expenses (% of total expenses) in Lithuania in 2006 to that in 2011?
Make the answer very short. 1.3. What is the ratio of the Expenses (% of total expenses) in Sierra Leone in 2006 to that in 2011?
Your answer should be very brief. 1.21. What is the ratio of the Expenses (% of total expenses) of United Kingdom in 2006 to that in 2011?
Offer a very short reply. 1.1. What is the ratio of the Expenses (% of total expenses) in Lithuania in 2007 to that in 2008?
Keep it short and to the point. 1.01. What is the ratio of the Expenses (% of total expenses) of Sierra Leone in 2007 to that in 2008?
Your response must be concise. 1.28. What is the ratio of the Expenses (% of total expenses) in United Kingdom in 2007 to that in 2008?
Ensure brevity in your answer.  1.09. What is the ratio of the Expenses (% of total expenses) in Central Europe in 2007 to that in 2009?
Provide a succinct answer. 1.2. What is the ratio of the Expenses (% of total expenses) in Lithuania in 2007 to that in 2009?
Ensure brevity in your answer.  1.1. What is the ratio of the Expenses (% of total expenses) of Sierra Leone in 2007 to that in 2009?
Your answer should be very brief. 1.3. What is the ratio of the Expenses (% of total expenses) in United Kingdom in 2007 to that in 2009?
Ensure brevity in your answer.  1.1. What is the ratio of the Expenses (% of total expenses) in Central Europe in 2007 to that in 2010?
Your answer should be compact. 1.25. What is the ratio of the Expenses (% of total expenses) in Lithuania in 2007 to that in 2010?
Offer a terse response. 1.21. What is the ratio of the Expenses (% of total expenses) in Sierra Leone in 2007 to that in 2010?
Your answer should be very brief. 1.39. What is the ratio of the Expenses (% of total expenses) of United Kingdom in 2007 to that in 2010?
Keep it short and to the point. 1.1. What is the ratio of the Expenses (% of total expenses) in Central Europe in 2007 to that in 2011?
Keep it short and to the point. 1.35. What is the ratio of the Expenses (% of total expenses) in Lithuania in 2007 to that in 2011?
Your response must be concise. 1.18. What is the ratio of the Expenses (% of total expenses) of Sierra Leone in 2007 to that in 2011?
Your answer should be compact. 1.45. What is the ratio of the Expenses (% of total expenses) of United Kingdom in 2007 to that in 2011?
Offer a terse response. 1.07. What is the ratio of the Expenses (% of total expenses) in Central Europe in 2008 to that in 2009?
Your answer should be very brief. 1.21. What is the ratio of the Expenses (% of total expenses) in Lithuania in 2008 to that in 2009?
Provide a short and direct response. 1.08. What is the ratio of the Expenses (% of total expenses) of Sierra Leone in 2008 to that in 2009?
Ensure brevity in your answer.  1.02. What is the ratio of the Expenses (% of total expenses) in United Kingdom in 2008 to that in 2009?
Your answer should be compact. 1.01. What is the ratio of the Expenses (% of total expenses) of Central Europe in 2008 to that in 2010?
Your answer should be compact. 1.26. What is the ratio of the Expenses (% of total expenses) in Lithuania in 2008 to that in 2010?
Your response must be concise. 1.2. What is the ratio of the Expenses (% of total expenses) in Sierra Leone in 2008 to that in 2010?
Provide a short and direct response. 1.09. What is the ratio of the Expenses (% of total expenses) of United Kingdom in 2008 to that in 2010?
Ensure brevity in your answer.  1.01. What is the ratio of the Expenses (% of total expenses) in Central Europe in 2008 to that in 2011?
Offer a very short reply. 1.36. What is the ratio of the Expenses (% of total expenses) of Lithuania in 2008 to that in 2011?
Keep it short and to the point. 1.16. What is the ratio of the Expenses (% of total expenses) in Sierra Leone in 2008 to that in 2011?
Offer a very short reply. 1.13. What is the ratio of the Expenses (% of total expenses) of United Kingdom in 2008 to that in 2011?
Make the answer very short. 0.98. What is the ratio of the Expenses (% of total expenses) in Central Europe in 2009 to that in 2010?
Ensure brevity in your answer.  1.04. What is the ratio of the Expenses (% of total expenses) of Lithuania in 2009 to that in 2010?
Ensure brevity in your answer.  1.11. What is the ratio of the Expenses (% of total expenses) in Sierra Leone in 2009 to that in 2010?
Offer a very short reply. 1.07. What is the ratio of the Expenses (% of total expenses) of United Kingdom in 2009 to that in 2010?
Provide a succinct answer. 1. What is the ratio of the Expenses (% of total expenses) of Central Europe in 2009 to that in 2011?
Make the answer very short. 1.12. What is the ratio of the Expenses (% of total expenses) in Lithuania in 2009 to that in 2011?
Ensure brevity in your answer.  1.07. What is the ratio of the Expenses (% of total expenses) of Sierra Leone in 2009 to that in 2011?
Offer a terse response. 1.12. What is the ratio of the Expenses (% of total expenses) in United Kingdom in 2009 to that in 2011?
Give a very brief answer. 0.97. What is the ratio of the Expenses (% of total expenses) in Central Europe in 2010 to that in 2011?
Offer a very short reply. 1.08. What is the ratio of the Expenses (% of total expenses) in Lithuania in 2010 to that in 2011?
Offer a terse response. 0.97. What is the ratio of the Expenses (% of total expenses) in Sierra Leone in 2010 to that in 2011?
Your response must be concise. 1.04. What is the ratio of the Expenses (% of total expenses) of United Kingdom in 2010 to that in 2011?
Your answer should be very brief. 0.98. What is the difference between the highest and the second highest Expenses (% of total expenses) in Central Europe?
Provide a short and direct response. 0.13. What is the difference between the highest and the second highest Expenses (% of total expenses) of Lithuania?
Your answer should be very brief. 0.11. What is the difference between the highest and the second highest Expenses (% of total expenses) of Sierra Leone?
Offer a very short reply. 5.93. What is the difference between the highest and the second highest Expenses (% of total expenses) of United Kingdom?
Offer a very short reply. 0.38. What is the difference between the highest and the lowest Expenses (% of total expenses) of Central Europe?
Keep it short and to the point. 4.81. What is the difference between the highest and the lowest Expenses (% of total expenses) of Lithuania?
Provide a succinct answer. 5.02. What is the difference between the highest and the lowest Expenses (% of total expenses) in Sierra Leone?
Provide a short and direct response. 11.11. What is the difference between the highest and the lowest Expenses (% of total expenses) of United Kingdom?
Give a very brief answer. 1.71. 